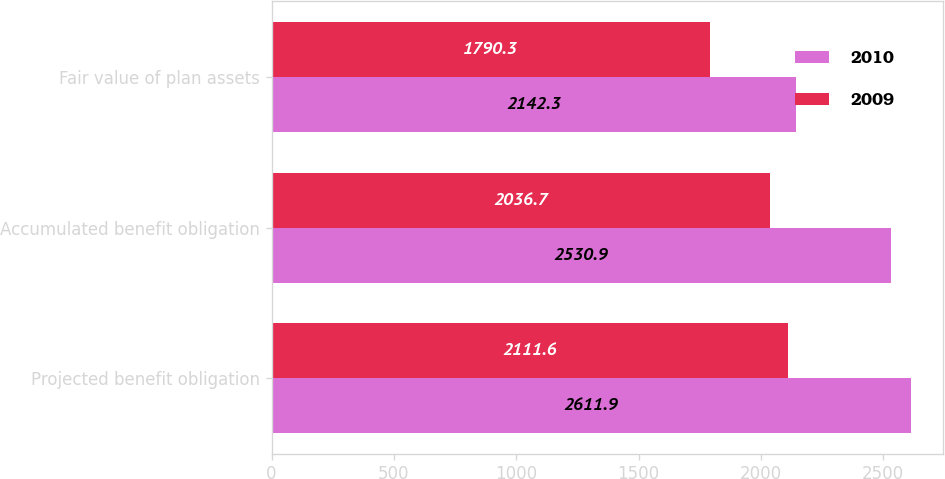Convert chart to OTSL. <chart><loc_0><loc_0><loc_500><loc_500><stacked_bar_chart><ecel><fcel>Projected benefit obligation<fcel>Accumulated benefit obligation<fcel>Fair value of plan assets<nl><fcel>2010<fcel>2611.9<fcel>2530.9<fcel>2142.3<nl><fcel>2009<fcel>2111.6<fcel>2036.7<fcel>1790.3<nl></chart> 